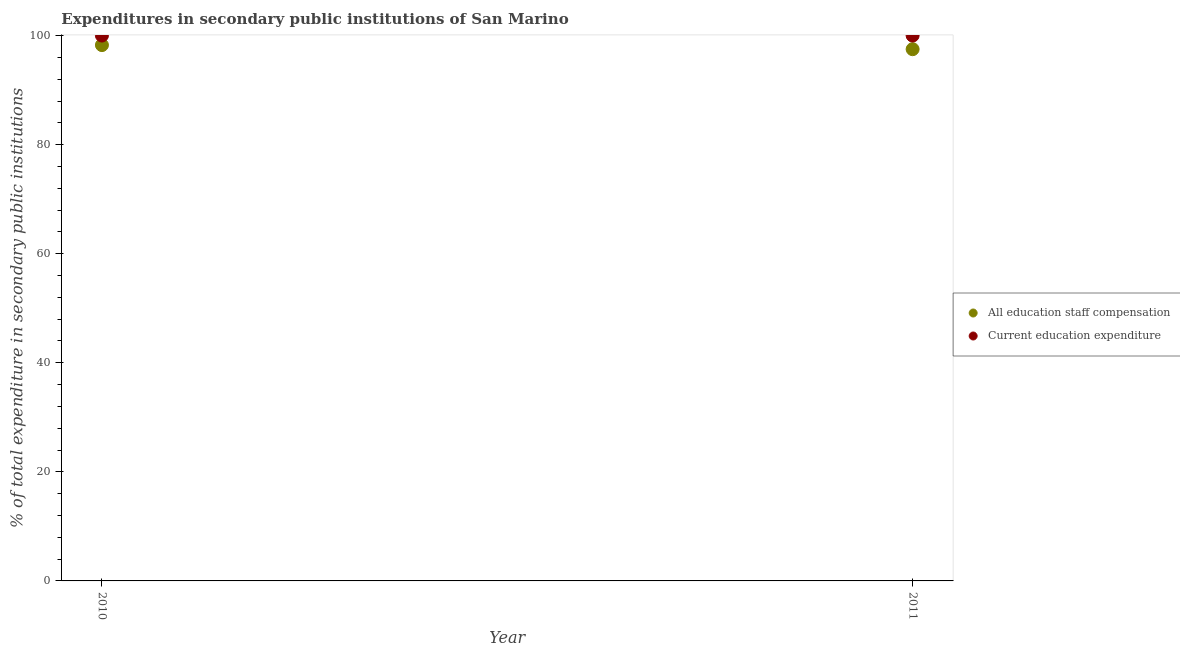How many different coloured dotlines are there?
Your answer should be very brief. 2. Is the number of dotlines equal to the number of legend labels?
Your response must be concise. Yes. What is the expenditure in education in 2010?
Your response must be concise. 100. Across all years, what is the maximum expenditure in education?
Your answer should be very brief. 100. Across all years, what is the minimum expenditure in education?
Your answer should be very brief. 100. In which year was the expenditure in staff compensation maximum?
Provide a succinct answer. 2010. In which year was the expenditure in staff compensation minimum?
Ensure brevity in your answer.  2011. What is the total expenditure in education in the graph?
Offer a very short reply. 200. What is the difference between the expenditure in education in 2010 and that in 2011?
Offer a terse response. 0. What is the difference between the expenditure in education in 2011 and the expenditure in staff compensation in 2010?
Provide a succinct answer. 1.75. In the year 2010, what is the difference between the expenditure in staff compensation and expenditure in education?
Make the answer very short. -1.75. Is the expenditure in staff compensation in 2010 less than that in 2011?
Make the answer very short. No. In how many years, is the expenditure in education greater than the average expenditure in education taken over all years?
Ensure brevity in your answer.  0. How many dotlines are there?
Your response must be concise. 2. How many years are there in the graph?
Provide a short and direct response. 2. Does the graph contain any zero values?
Keep it short and to the point. No. Does the graph contain grids?
Offer a very short reply. No. Where does the legend appear in the graph?
Your response must be concise. Center right. How many legend labels are there?
Provide a short and direct response. 2. How are the legend labels stacked?
Your answer should be very brief. Vertical. What is the title of the graph?
Give a very brief answer. Expenditures in secondary public institutions of San Marino. Does "Exports" appear as one of the legend labels in the graph?
Give a very brief answer. No. What is the label or title of the Y-axis?
Keep it short and to the point. % of total expenditure in secondary public institutions. What is the % of total expenditure in secondary public institutions in All education staff compensation in 2010?
Offer a terse response. 98.25. What is the % of total expenditure in secondary public institutions of All education staff compensation in 2011?
Your response must be concise. 97.5. What is the % of total expenditure in secondary public institutions of Current education expenditure in 2011?
Your answer should be compact. 100. Across all years, what is the maximum % of total expenditure in secondary public institutions of All education staff compensation?
Offer a terse response. 98.25. Across all years, what is the minimum % of total expenditure in secondary public institutions in All education staff compensation?
Your response must be concise. 97.5. Across all years, what is the minimum % of total expenditure in secondary public institutions of Current education expenditure?
Keep it short and to the point. 100. What is the total % of total expenditure in secondary public institutions of All education staff compensation in the graph?
Give a very brief answer. 195.75. What is the total % of total expenditure in secondary public institutions of Current education expenditure in the graph?
Keep it short and to the point. 200. What is the difference between the % of total expenditure in secondary public institutions of All education staff compensation in 2010 and that in 2011?
Provide a short and direct response. 0.75. What is the difference between the % of total expenditure in secondary public institutions in Current education expenditure in 2010 and that in 2011?
Offer a terse response. 0. What is the difference between the % of total expenditure in secondary public institutions of All education staff compensation in 2010 and the % of total expenditure in secondary public institutions of Current education expenditure in 2011?
Your answer should be compact. -1.75. What is the average % of total expenditure in secondary public institutions in All education staff compensation per year?
Provide a succinct answer. 97.88. In the year 2010, what is the difference between the % of total expenditure in secondary public institutions in All education staff compensation and % of total expenditure in secondary public institutions in Current education expenditure?
Offer a very short reply. -1.75. In the year 2011, what is the difference between the % of total expenditure in secondary public institutions in All education staff compensation and % of total expenditure in secondary public institutions in Current education expenditure?
Offer a very short reply. -2.5. What is the ratio of the % of total expenditure in secondary public institutions of All education staff compensation in 2010 to that in 2011?
Your response must be concise. 1.01. What is the ratio of the % of total expenditure in secondary public institutions in Current education expenditure in 2010 to that in 2011?
Keep it short and to the point. 1. What is the difference between the highest and the second highest % of total expenditure in secondary public institutions in All education staff compensation?
Provide a succinct answer. 0.75. What is the difference between the highest and the lowest % of total expenditure in secondary public institutions of All education staff compensation?
Ensure brevity in your answer.  0.75. What is the difference between the highest and the lowest % of total expenditure in secondary public institutions in Current education expenditure?
Give a very brief answer. 0. 